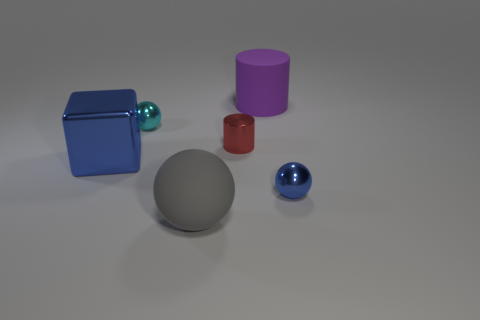Subtract all gray matte spheres. How many spheres are left? 2 Subtract 1 spheres. How many spheres are left? 2 Add 4 brown metal cylinders. How many objects exist? 10 Subtract all cubes. How many objects are left? 5 Subtract all small gray rubber balls. Subtract all large gray balls. How many objects are left? 5 Add 4 small metal cylinders. How many small metal cylinders are left? 5 Add 6 big cyan rubber cubes. How many big cyan rubber cubes exist? 6 Subtract 0 red balls. How many objects are left? 6 